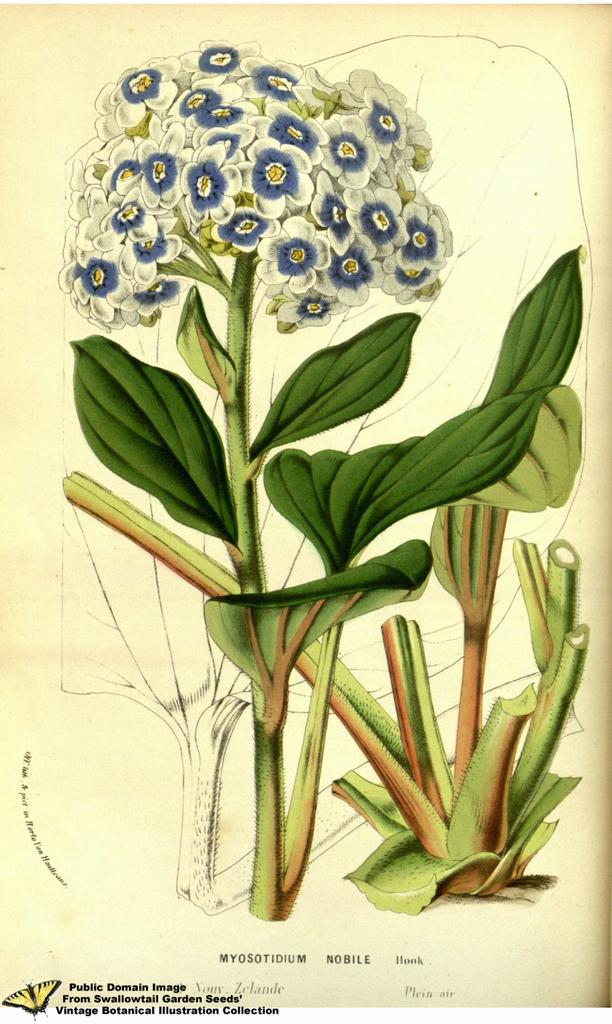What is depicted on the poster in the image? The poster contains flowers, plants, and text. Can you describe the content of the poster in more detail? The poster contains flowers and plants, which suggests it might be related to nature or gardening. Are there any additional elements on the poster? Yes, there is text on the poster. What can be seen on the left side bottom of the image? There are watermarks and a butterfly icon on the left side bottom of the image. What type of silver material is used to create the start button on the poster? There is no start button or silver material present in the image; it features a poster with flowers, plants, and text. 